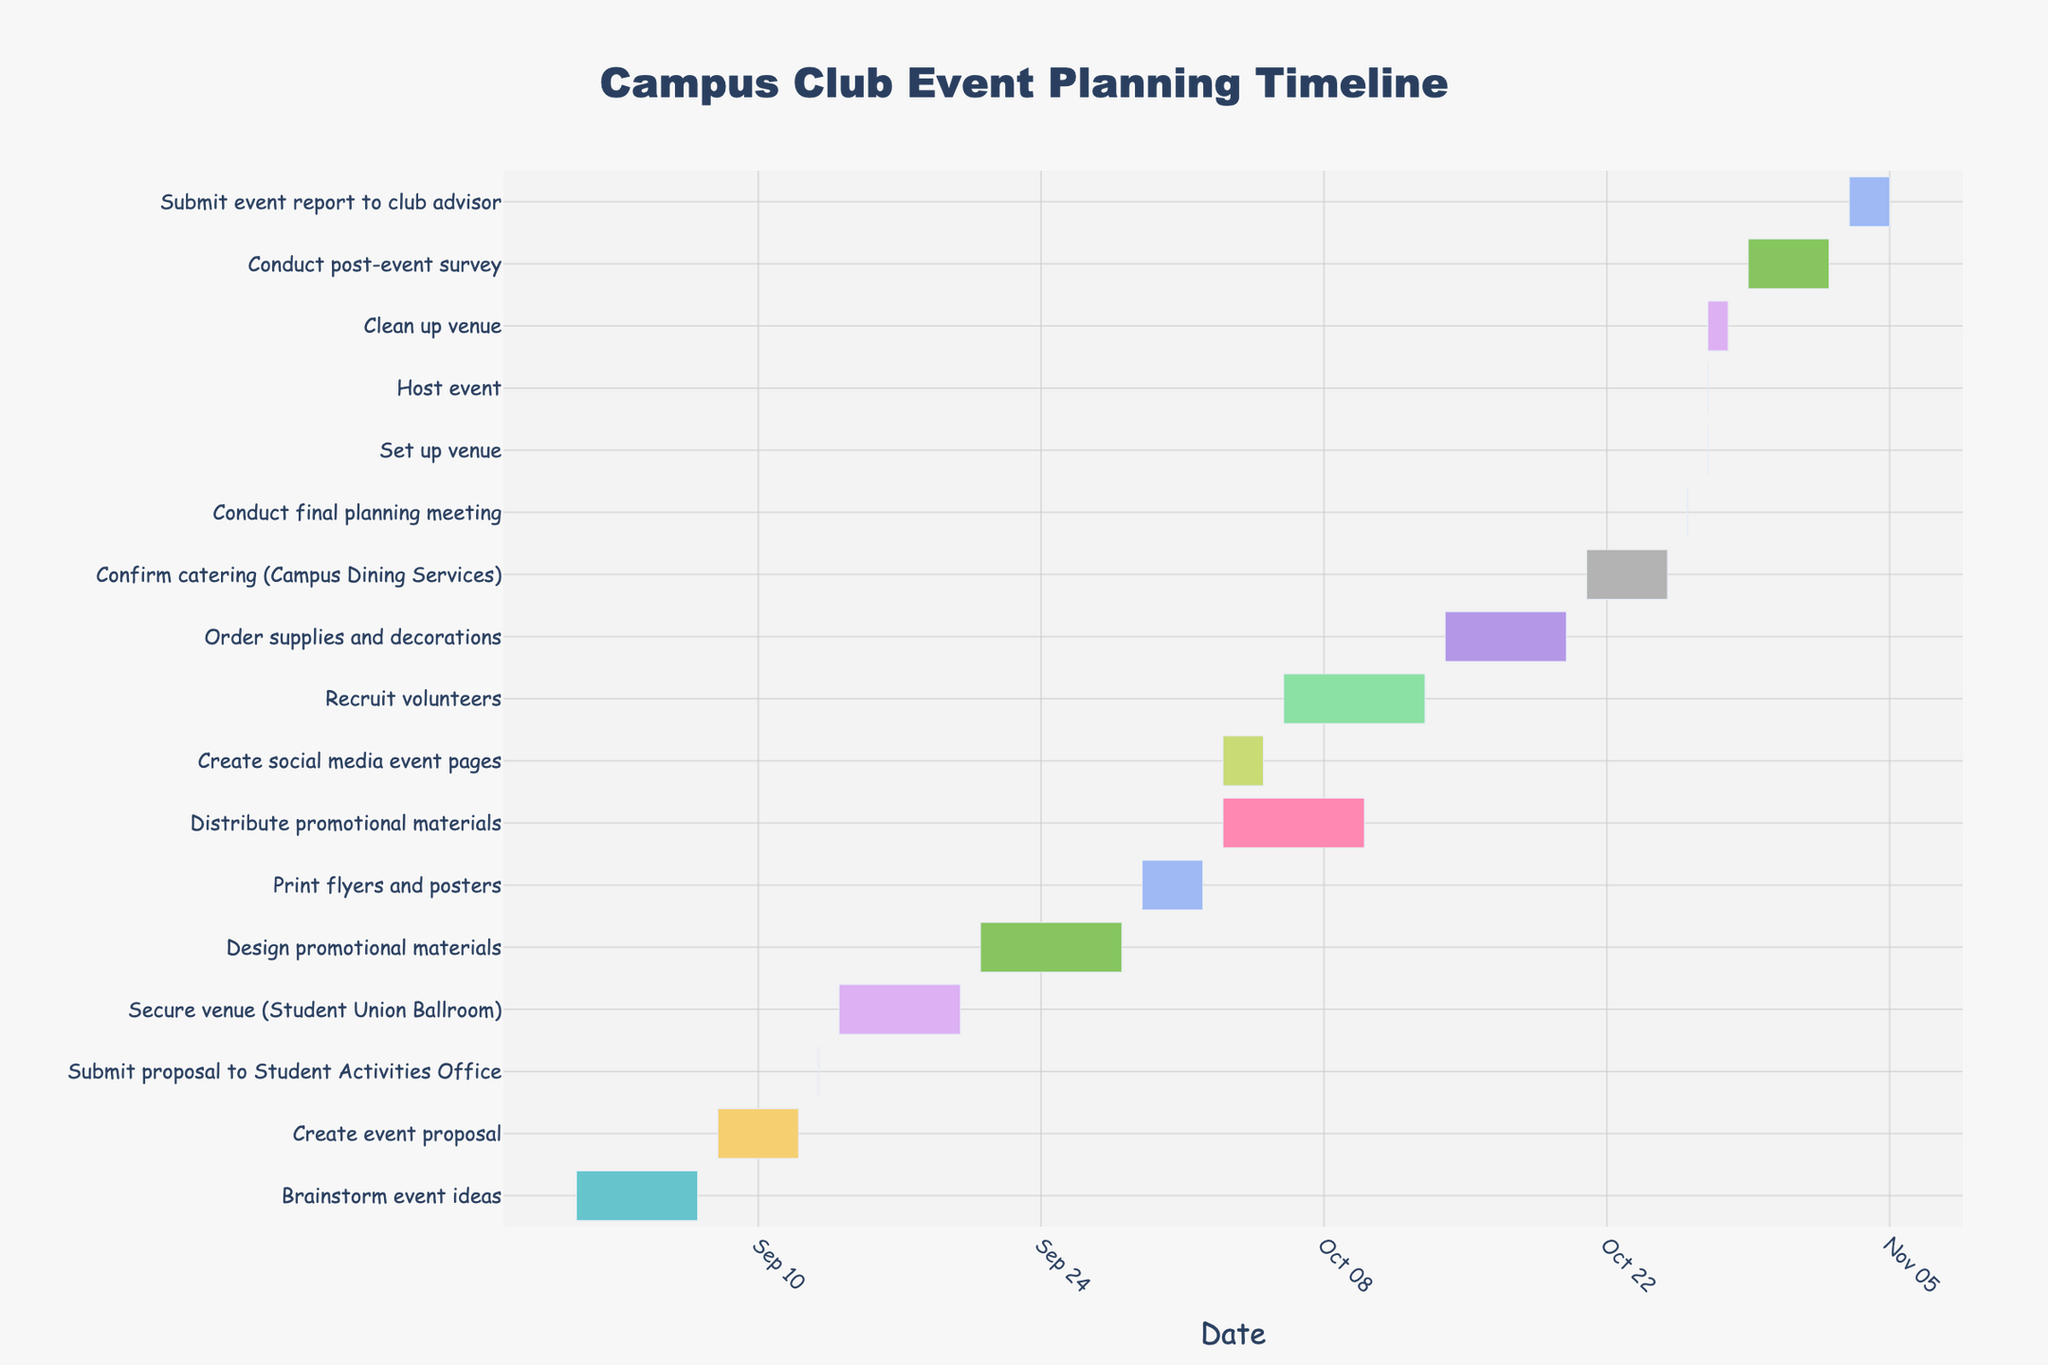What is the title of the Gantt chart? The title is usually found at the top of the chart. It helps explain what the figure is about. In this case, "Campus Club Event Planning Timeline" is shown.
Answer: Campus Club Event Planning Timeline When does the task "Design promotional materials" start and end? By locating "Design promotional materials" on the Gantt chart, we can see that it starts on September 21 and ends on September 28.
Answer: September 21 - September 28 How many tasks are there in total? Count the number of rows labeled with each task in the figure.
Answer: 16 Which task has the shortest duration? By observing the lengths of the horizontal bars, the shortest duration bar corresponds to the task "Submit proposal to Student Activities Office" as it starts and ends on September 13.
Answer: Submit proposal to Student Activities Office How long does the "Secure venue (Student Union Ballroom)" task take? Measure the length of the bar for this task, noting the start and end dates, from September 14 to September 20. The duration is 6 days.
Answer: 6 days Which tasks are scheduled to be executed on October 27? To find this, look for tasks with bars crossing October 27. "Set up venue," "Host event," and "Clean up venue" are all scheduled on this date.
Answer: Set up venue, Host event, Clean up venue How many tasks involve promotional activities? Identify tasks related to promotion in the task list: "Design promotional materials," "Print flyers and posters," "Distribute promotional materials," "Create social media event pages." Count these tasks.
Answer: 4 Which task spans the longest period? Compare all the bars' lengths and find the longest one. The task "Conduct post-event survey" spans from October 29 to November 2, which is 5 days.
Answer: Conduct post-event survey What are the start and end dates for the "Brainstorm event ideas" task? Locate the "Brainstorm event ideas" bar on the Gantt chart, which goes from September 1 to September 7.
Answer: September 1 - September 7 What is the time gap between "Submit event report to club advisor" and the previous task? Notice "Submit event report to club advisor" starts on November 3 and "Conduct post-event survey" ends on November 2. The gap between them is 1 day.
Answer: 1 day 